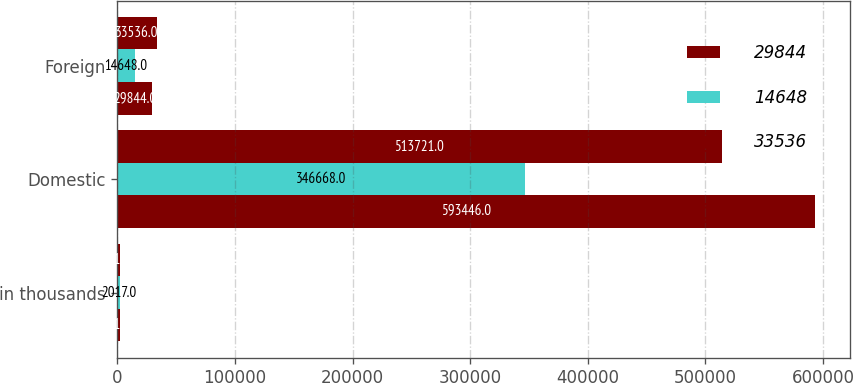Convert chart. <chart><loc_0><loc_0><loc_500><loc_500><stacked_bar_chart><ecel><fcel>in thousands<fcel>Domestic<fcel>Foreign<nl><fcel>29844<fcel>2018<fcel>593446<fcel>29844<nl><fcel>14648<fcel>2017<fcel>346668<fcel>14648<nl><fcel>33536<fcel>2016<fcel>513721<fcel>33536<nl></chart> 